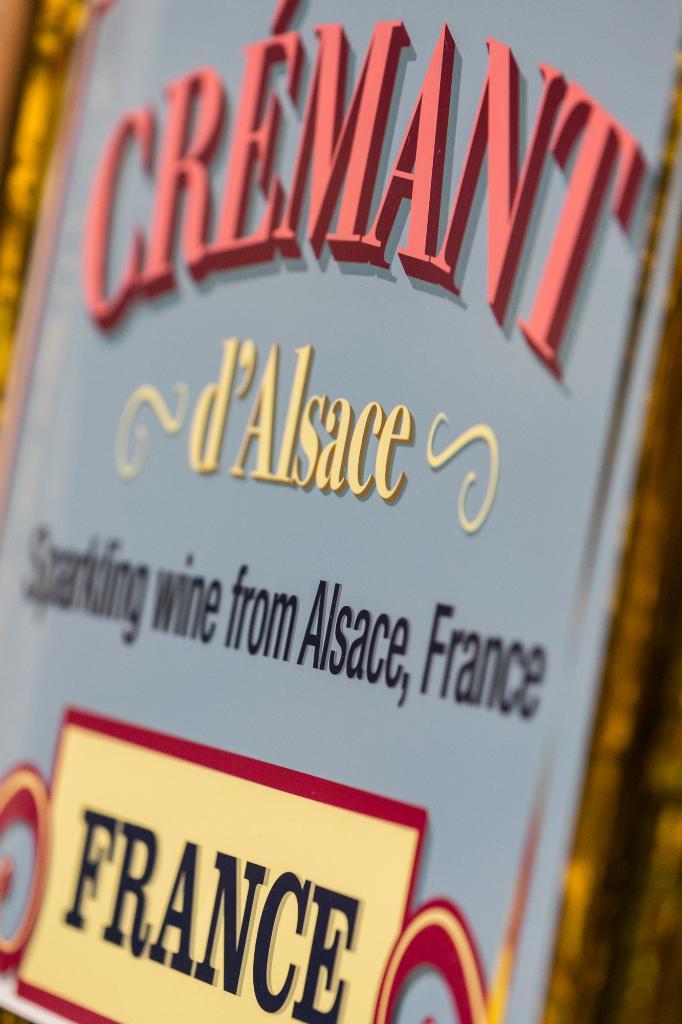What is the country on this sign?
Your answer should be very brief. France. What is the name of the organizer shown in the poster?
Provide a succinct answer. Cremant. 